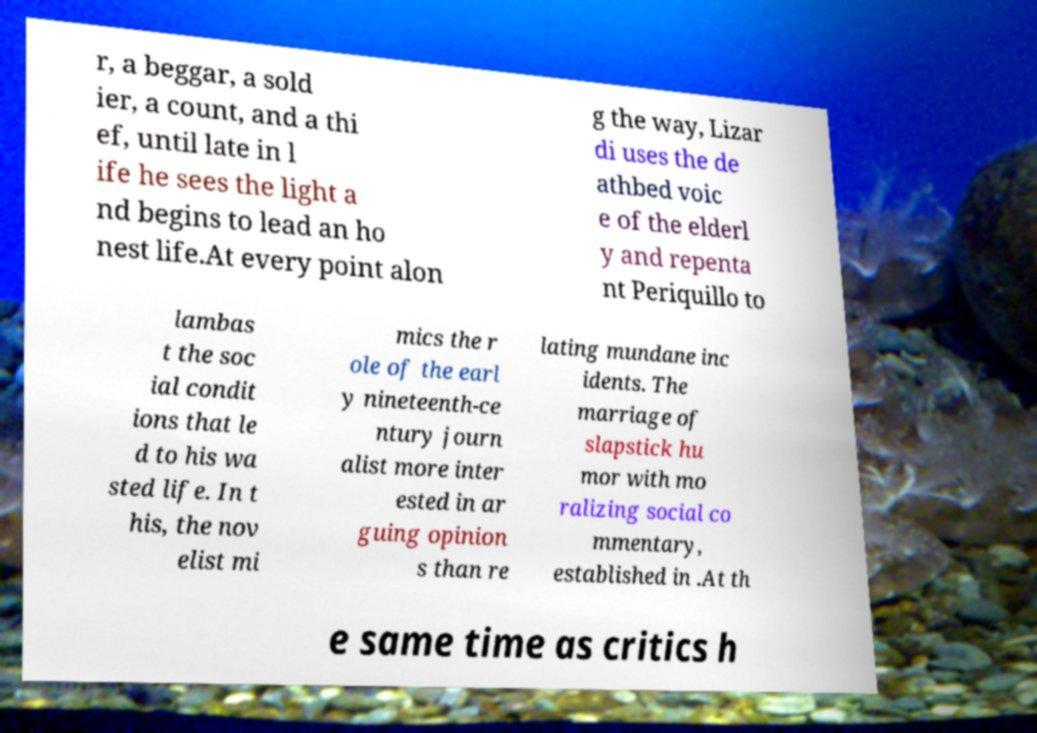Please identify and transcribe the text found in this image. r, a beggar, a sold ier, a count, and a thi ef, until late in l ife he sees the light a nd begins to lead an ho nest life.At every point alon g the way, Lizar di uses the de athbed voic e of the elderl y and repenta nt Periquillo to lambas t the soc ial condit ions that le d to his wa sted life. In t his, the nov elist mi mics the r ole of the earl y nineteenth-ce ntury journ alist more inter ested in ar guing opinion s than re lating mundane inc idents. The marriage of slapstick hu mor with mo ralizing social co mmentary, established in .At th e same time as critics h 